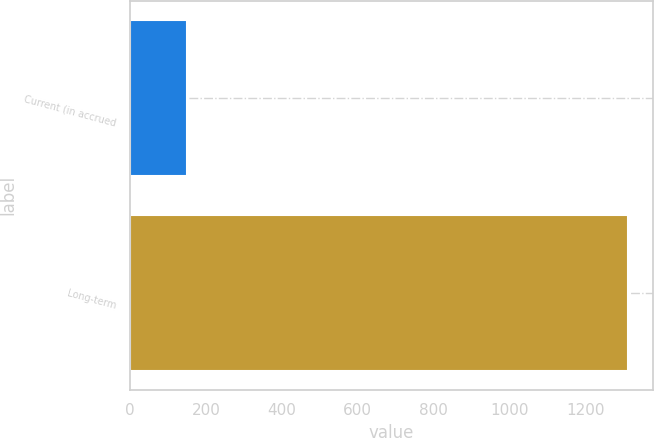<chart> <loc_0><loc_0><loc_500><loc_500><bar_chart><fcel>Current (in accrued<fcel>Long-term<nl><fcel>150<fcel>1312<nl></chart> 